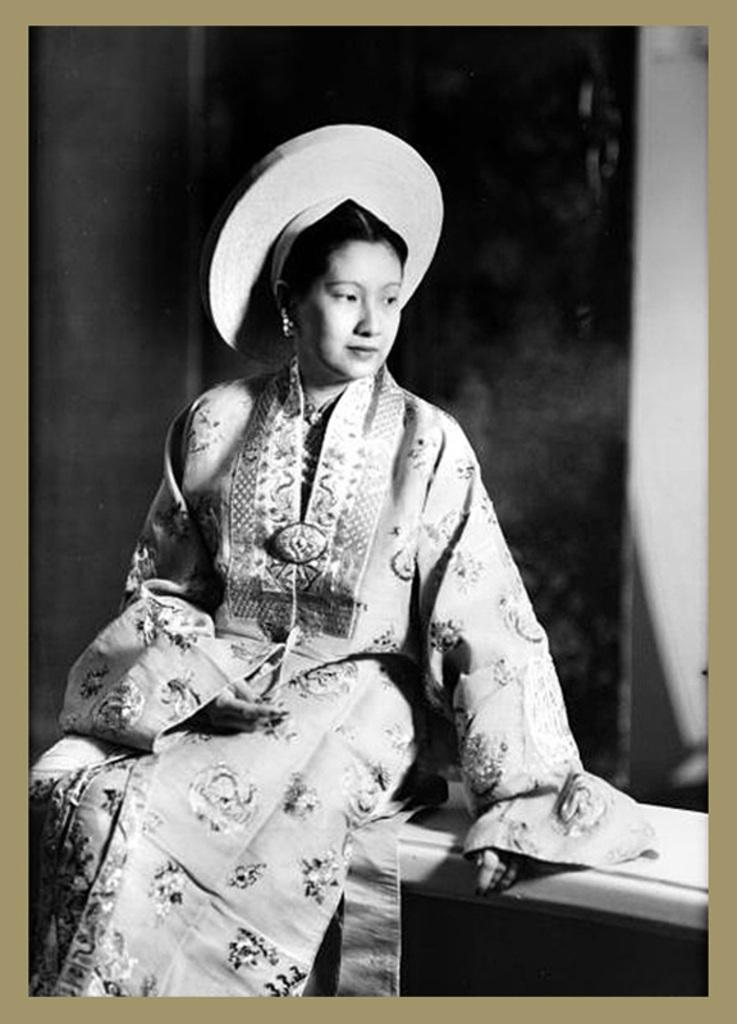Who is present in the image? There is a woman in the image. What is the woman wearing on her head? The woman is wearing a hat on her head. What is the color scheme of the image? The image is black and white. What type of disease is the woman suffering from in the image? There is no indication of any disease in the image; it only shows a woman wearing a hat. How many teeth can be seen in the woman's mouth in the image? The image is black and white and does not show the woman's teeth, so it is impossible to determine the number of teeth. 